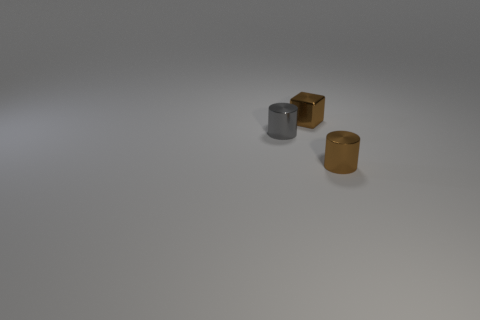Is there another gray shiny cylinder of the same size as the gray cylinder?
Offer a terse response. No. Does the cylinder on the right side of the block have the same size as the tiny metallic block?
Ensure brevity in your answer.  Yes. What shape is the metallic object that is both in front of the tiny brown cube and right of the gray shiny object?
Ensure brevity in your answer.  Cylinder. Is the number of brown blocks in front of the tiny brown metallic cube greater than the number of brown cubes?
Your answer should be compact. No. The brown cylinder that is the same material as the tiny brown block is what size?
Provide a short and direct response. Small. How many other tiny metallic blocks have the same color as the metal cube?
Make the answer very short. 0. There is a cylinder in front of the tiny gray object; does it have the same color as the cube?
Provide a short and direct response. Yes. Is the number of gray cylinders behind the metallic cube the same as the number of gray cylinders that are in front of the small brown cylinder?
Give a very brief answer. Yes. Are there any other things that have the same material as the tiny block?
Ensure brevity in your answer.  Yes. What color is the shiny object that is on the left side of the small brown metal block?
Offer a very short reply. Gray. 